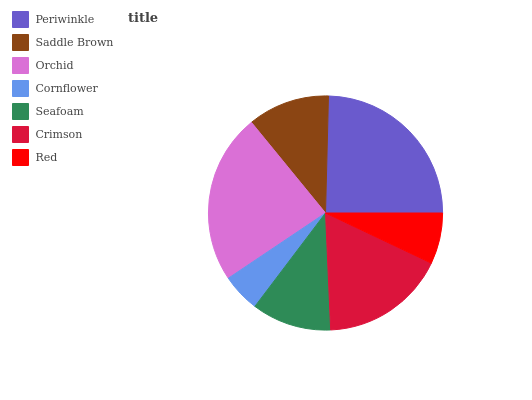Is Cornflower the minimum?
Answer yes or no. Yes. Is Periwinkle the maximum?
Answer yes or no. Yes. Is Saddle Brown the minimum?
Answer yes or no. No. Is Saddle Brown the maximum?
Answer yes or no. No. Is Periwinkle greater than Saddle Brown?
Answer yes or no. Yes. Is Saddle Brown less than Periwinkle?
Answer yes or no. Yes. Is Saddle Brown greater than Periwinkle?
Answer yes or no. No. Is Periwinkle less than Saddle Brown?
Answer yes or no. No. Is Saddle Brown the high median?
Answer yes or no. Yes. Is Saddle Brown the low median?
Answer yes or no. Yes. Is Orchid the high median?
Answer yes or no. No. Is Periwinkle the low median?
Answer yes or no. No. 